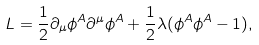<formula> <loc_0><loc_0><loc_500><loc_500>L = \frac { 1 } { 2 } \partial _ { \mu } \phi ^ { A } \partial ^ { \mu } \phi ^ { A } + \frac { 1 } { 2 } \lambda ( \phi ^ { A } \phi ^ { A } - 1 ) ,</formula> 